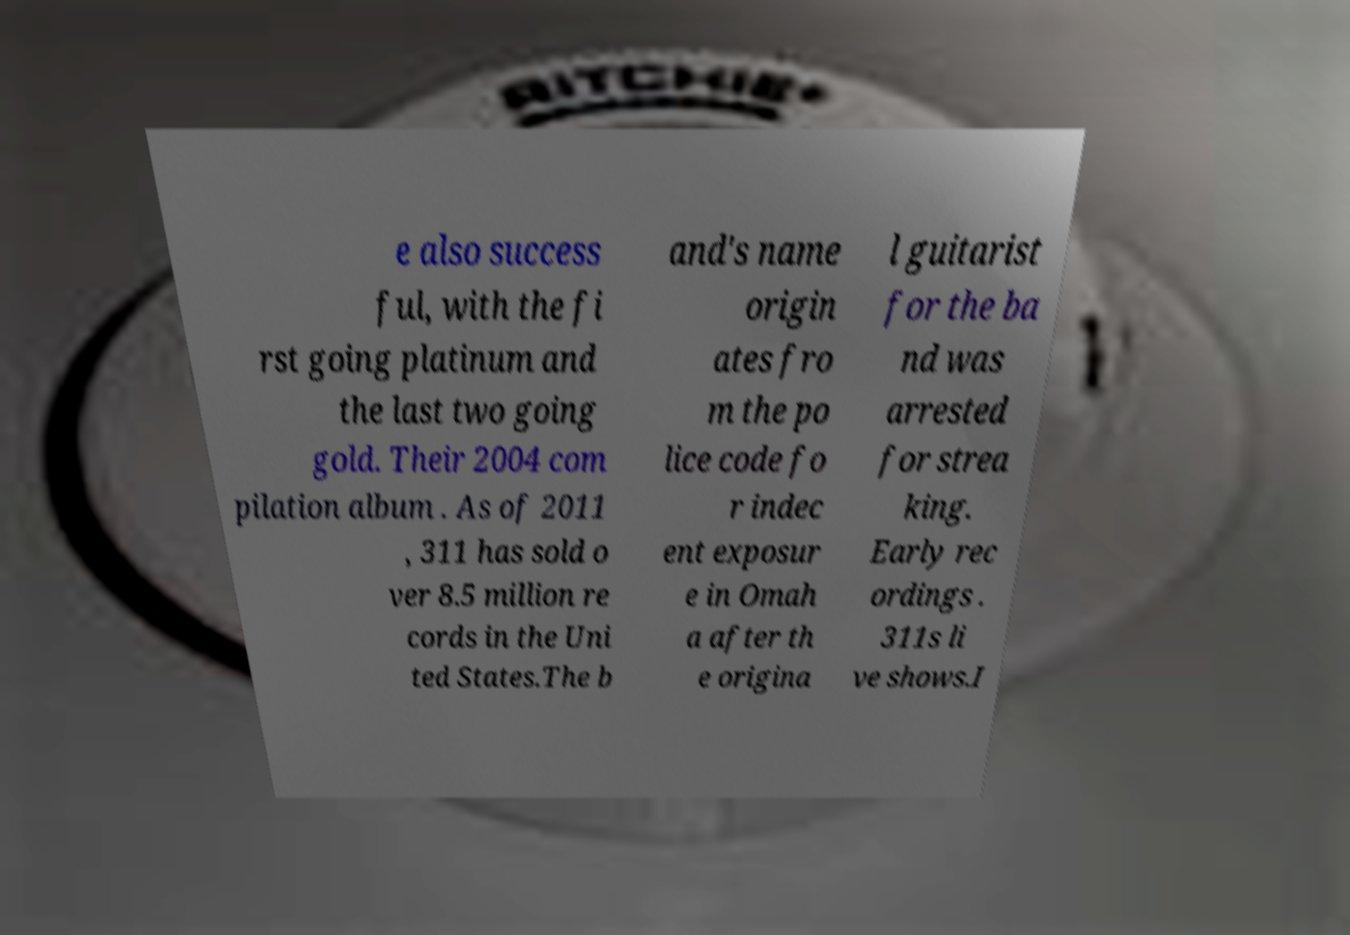There's text embedded in this image that I need extracted. Can you transcribe it verbatim? e also success ful, with the fi rst going platinum and the last two going gold. Their 2004 com pilation album . As of 2011 , 311 has sold o ver 8.5 million re cords in the Uni ted States.The b and's name origin ates fro m the po lice code fo r indec ent exposur e in Omah a after th e origina l guitarist for the ba nd was arrested for strea king. Early rec ordings . 311s li ve shows.I 